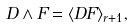<formula> <loc_0><loc_0><loc_500><loc_500>D \wedge F = \langle D F \rangle _ { r + 1 } ,</formula> 